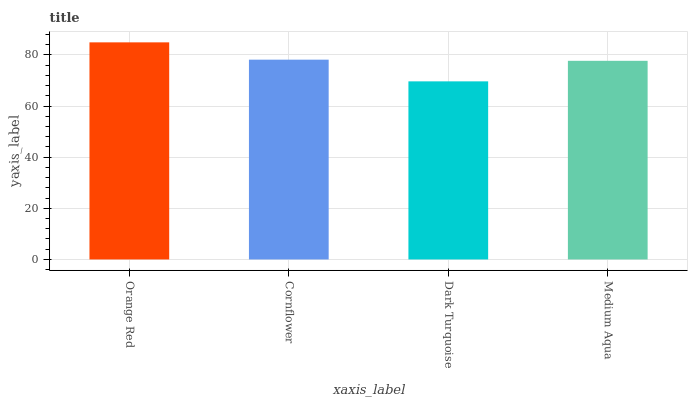Is Dark Turquoise the minimum?
Answer yes or no. Yes. Is Orange Red the maximum?
Answer yes or no. Yes. Is Cornflower the minimum?
Answer yes or no. No. Is Cornflower the maximum?
Answer yes or no. No. Is Orange Red greater than Cornflower?
Answer yes or no. Yes. Is Cornflower less than Orange Red?
Answer yes or no. Yes. Is Cornflower greater than Orange Red?
Answer yes or no. No. Is Orange Red less than Cornflower?
Answer yes or no. No. Is Cornflower the high median?
Answer yes or no. Yes. Is Medium Aqua the low median?
Answer yes or no. Yes. Is Orange Red the high median?
Answer yes or no. No. Is Orange Red the low median?
Answer yes or no. No. 